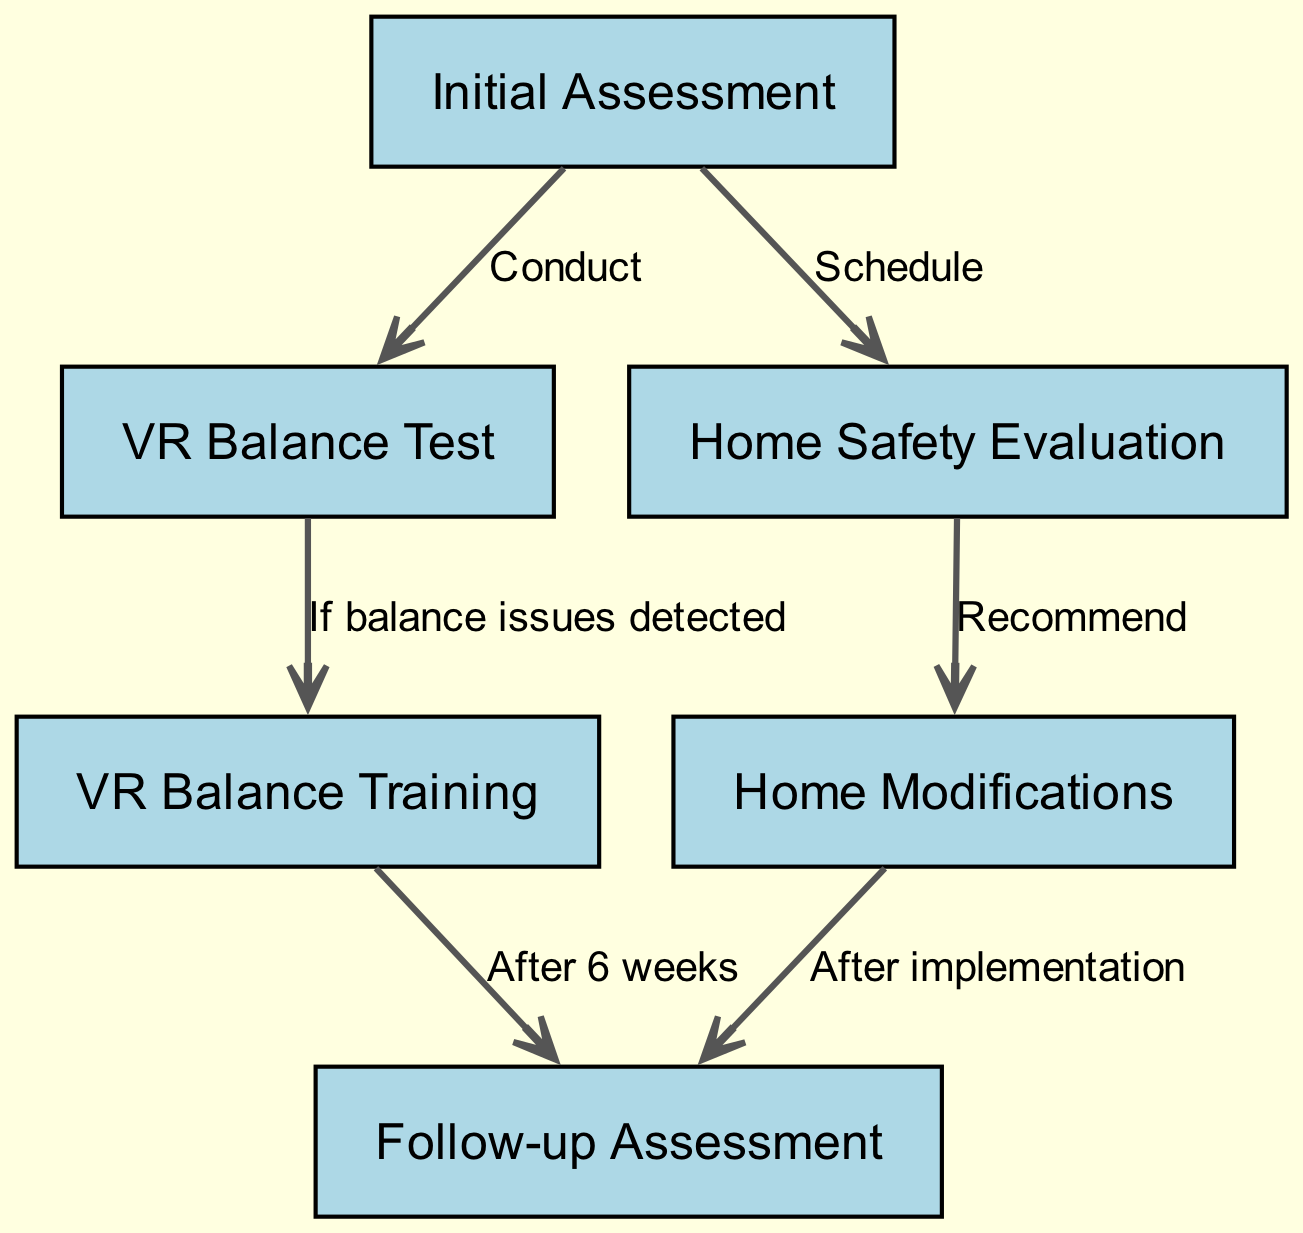What is the first step in the clinical pathway? The first step, indicated by the first node in the diagram, is "Initial Assessment".
Answer: Initial Assessment How many nodes are there in total? By counting all the nodes listed in the diagram, there are six nodes included.
Answer: 6 What follows the "VR Balance Test" if balance issues are detected? The edge from "VR Balance Test" directs to "VR Balance Training" if balance issues are detected, as indicated in the diagram.
Answer: VR Balance Training What is recommended after the "Home Safety Evaluation"? According to the diagram, the recommendation after the "Home Safety Evaluation" is "Home Modifications".
Answer: Home Modifications How long after "VR Balance Training" is the follow-up assessment scheduled? The diagram specifies that the follow-up assessment occurs "After 6 weeks" of completing "VR Balance Training".
Answer: After 6 weeks Which nodes lead to the "Follow-up Assessment"? The "Follow-up Assessment" is reached by two edges: one from "VR Balance Training" and another from "Home Modifications" after their respective actions are completed.
Answer: VR Balance Training, Home Modifications What does the edge from "Initial Assessment" to "Home Safety Evaluation" indicate? This edge indicates that a "Home Safety Evaluation" should be scheduled following the "Initial Assessment".
Answer: Schedule What is the purpose of the "VR Balance Test" in the pathway? The "VR Balance Test" serves to identify any balance issues that may require further intervention, specifically "VR Balance Training".
Answer: Identify balance issues 